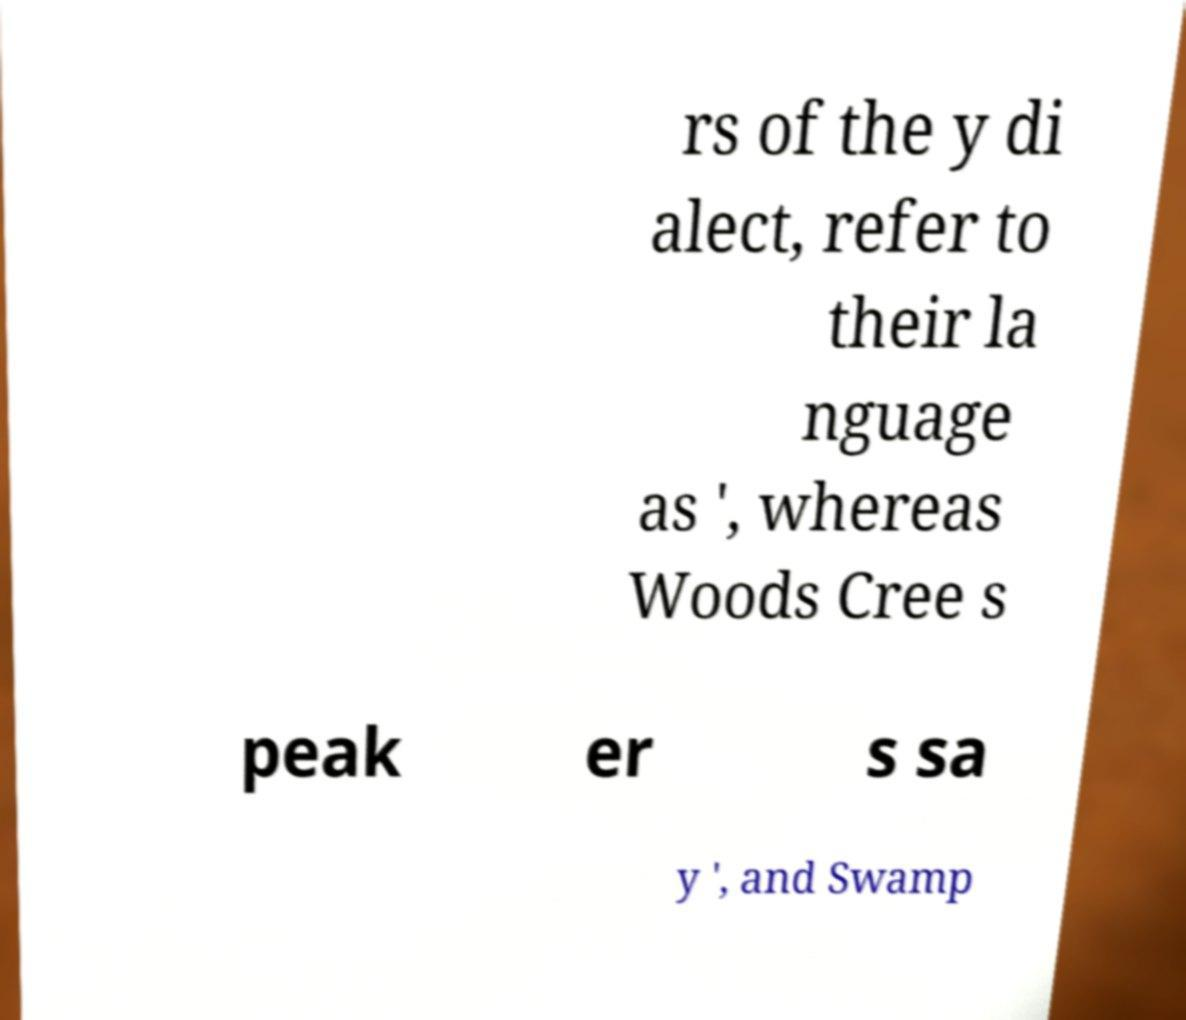I need the written content from this picture converted into text. Can you do that? rs of the y di alect, refer to their la nguage as ', whereas Woods Cree s peak er s sa y ', and Swamp 